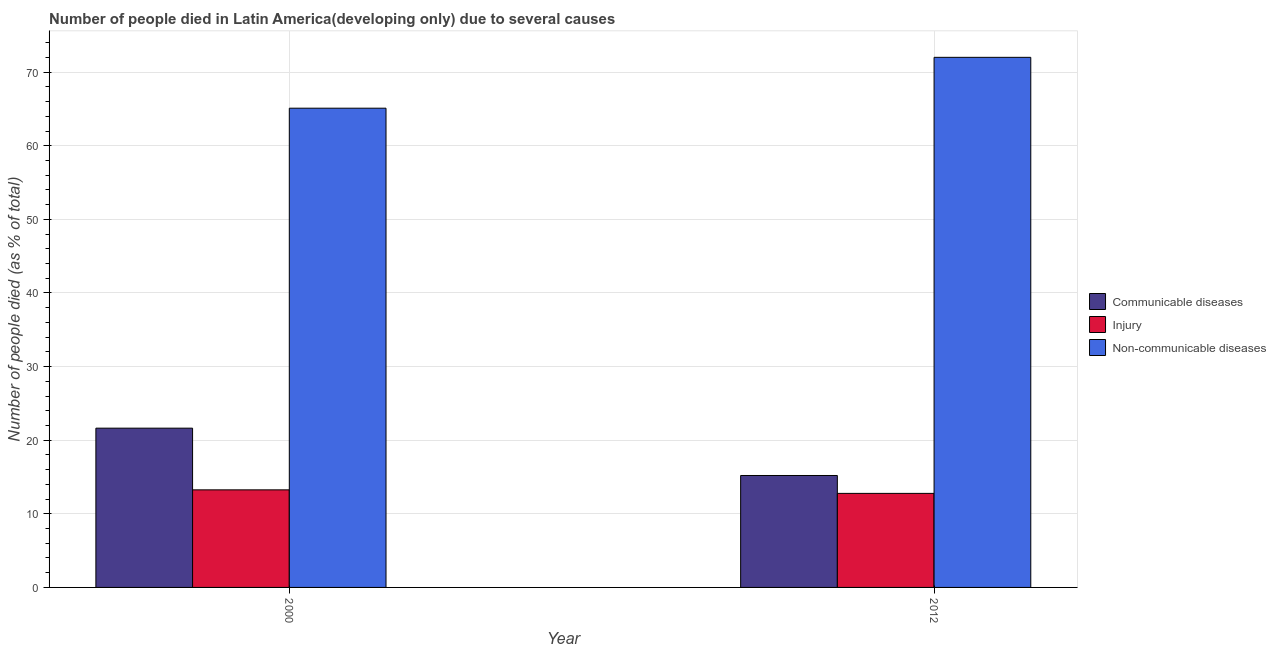How many different coloured bars are there?
Your answer should be compact. 3. How many groups of bars are there?
Ensure brevity in your answer.  2. Are the number of bars on each tick of the X-axis equal?
Make the answer very short. Yes. What is the number of people who died of communicable diseases in 2000?
Keep it short and to the point. 21.64. Across all years, what is the maximum number of people who died of communicable diseases?
Offer a very short reply. 21.64. Across all years, what is the minimum number of people who died of communicable diseases?
Make the answer very short. 15.21. In which year was the number of people who died of injury minimum?
Your response must be concise. 2012. What is the total number of people who died of injury in the graph?
Offer a very short reply. 26.03. What is the difference between the number of people who died of communicable diseases in 2000 and that in 2012?
Provide a short and direct response. 6.43. What is the difference between the number of people who dies of non-communicable diseases in 2000 and the number of people who died of injury in 2012?
Provide a succinct answer. -6.91. What is the average number of people who dies of non-communicable diseases per year?
Your answer should be very brief. 68.56. In how many years, is the number of people who died of injury greater than 46 %?
Offer a terse response. 0. What is the ratio of the number of people who died of communicable diseases in 2000 to that in 2012?
Keep it short and to the point. 1.42. Is the number of people who died of injury in 2000 less than that in 2012?
Provide a short and direct response. No. In how many years, is the number of people who died of communicable diseases greater than the average number of people who died of communicable diseases taken over all years?
Ensure brevity in your answer.  1. What does the 3rd bar from the left in 2012 represents?
Make the answer very short. Non-communicable diseases. What does the 3rd bar from the right in 2000 represents?
Your answer should be compact. Communicable diseases. What is the difference between two consecutive major ticks on the Y-axis?
Make the answer very short. 10. Does the graph contain grids?
Ensure brevity in your answer.  Yes. Where does the legend appear in the graph?
Your response must be concise. Center right. How many legend labels are there?
Offer a terse response. 3. How are the legend labels stacked?
Give a very brief answer. Vertical. What is the title of the graph?
Your answer should be very brief. Number of people died in Latin America(developing only) due to several causes. What is the label or title of the Y-axis?
Make the answer very short. Number of people died (as % of total). What is the Number of people died (as % of total) in Communicable diseases in 2000?
Ensure brevity in your answer.  21.64. What is the Number of people died (as % of total) of Injury in 2000?
Offer a terse response. 13.26. What is the Number of people died (as % of total) in Non-communicable diseases in 2000?
Your response must be concise. 65.11. What is the Number of people died (as % of total) in Communicable diseases in 2012?
Your answer should be compact. 15.21. What is the Number of people died (as % of total) in Injury in 2012?
Your answer should be very brief. 12.78. What is the Number of people died (as % of total) of Non-communicable diseases in 2012?
Make the answer very short. 72.02. Across all years, what is the maximum Number of people died (as % of total) of Communicable diseases?
Your response must be concise. 21.64. Across all years, what is the maximum Number of people died (as % of total) in Injury?
Offer a terse response. 13.26. Across all years, what is the maximum Number of people died (as % of total) in Non-communicable diseases?
Provide a short and direct response. 72.02. Across all years, what is the minimum Number of people died (as % of total) of Communicable diseases?
Your answer should be compact. 15.21. Across all years, what is the minimum Number of people died (as % of total) of Injury?
Provide a short and direct response. 12.78. Across all years, what is the minimum Number of people died (as % of total) in Non-communicable diseases?
Give a very brief answer. 65.11. What is the total Number of people died (as % of total) of Communicable diseases in the graph?
Offer a very short reply. 36.84. What is the total Number of people died (as % of total) of Injury in the graph?
Give a very brief answer. 26.03. What is the total Number of people died (as % of total) in Non-communicable diseases in the graph?
Keep it short and to the point. 137.12. What is the difference between the Number of people died (as % of total) in Communicable diseases in 2000 and that in 2012?
Make the answer very short. 6.43. What is the difference between the Number of people died (as % of total) in Injury in 2000 and that in 2012?
Provide a short and direct response. 0.48. What is the difference between the Number of people died (as % of total) in Non-communicable diseases in 2000 and that in 2012?
Your answer should be compact. -6.91. What is the difference between the Number of people died (as % of total) in Communicable diseases in 2000 and the Number of people died (as % of total) in Injury in 2012?
Keep it short and to the point. 8.86. What is the difference between the Number of people died (as % of total) in Communicable diseases in 2000 and the Number of people died (as % of total) in Non-communicable diseases in 2012?
Offer a very short reply. -50.38. What is the difference between the Number of people died (as % of total) in Injury in 2000 and the Number of people died (as % of total) in Non-communicable diseases in 2012?
Your answer should be very brief. -58.76. What is the average Number of people died (as % of total) of Communicable diseases per year?
Your response must be concise. 18.42. What is the average Number of people died (as % of total) of Injury per year?
Your answer should be very brief. 13.02. What is the average Number of people died (as % of total) of Non-communicable diseases per year?
Give a very brief answer. 68.56. In the year 2000, what is the difference between the Number of people died (as % of total) of Communicable diseases and Number of people died (as % of total) of Injury?
Make the answer very short. 8.38. In the year 2000, what is the difference between the Number of people died (as % of total) of Communicable diseases and Number of people died (as % of total) of Non-communicable diseases?
Offer a terse response. -43.47. In the year 2000, what is the difference between the Number of people died (as % of total) in Injury and Number of people died (as % of total) in Non-communicable diseases?
Keep it short and to the point. -51.85. In the year 2012, what is the difference between the Number of people died (as % of total) in Communicable diseases and Number of people died (as % of total) in Injury?
Your answer should be very brief. 2.43. In the year 2012, what is the difference between the Number of people died (as % of total) of Communicable diseases and Number of people died (as % of total) of Non-communicable diseases?
Keep it short and to the point. -56.81. In the year 2012, what is the difference between the Number of people died (as % of total) in Injury and Number of people died (as % of total) in Non-communicable diseases?
Offer a terse response. -59.24. What is the ratio of the Number of people died (as % of total) in Communicable diseases in 2000 to that in 2012?
Offer a terse response. 1.42. What is the ratio of the Number of people died (as % of total) in Injury in 2000 to that in 2012?
Ensure brevity in your answer.  1.04. What is the ratio of the Number of people died (as % of total) in Non-communicable diseases in 2000 to that in 2012?
Make the answer very short. 0.9. What is the difference between the highest and the second highest Number of people died (as % of total) in Communicable diseases?
Your answer should be very brief. 6.43. What is the difference between the highest and the second highest Number of people died (as % of total) in Injury?
Make the answer very short. 0.48. What is the difference between the highest and the second highest Number of people died (as % of total) of Non-communicable diseases?
Your answer should be compact. 6.91. What is the difference between the highest and the lowest Number of people died (as % of total) of Communicable diseases?
Your response must be concise. 6.43. What is the difference between the highest and the lowest Number of people died (as % of total) in Injury?
Give a very brief answer. 0.48. What is the difference between the highest and the lowest Number of people died (as % of total) of Non-communicable diseases?
Provide a short and direct response. 6.91. 